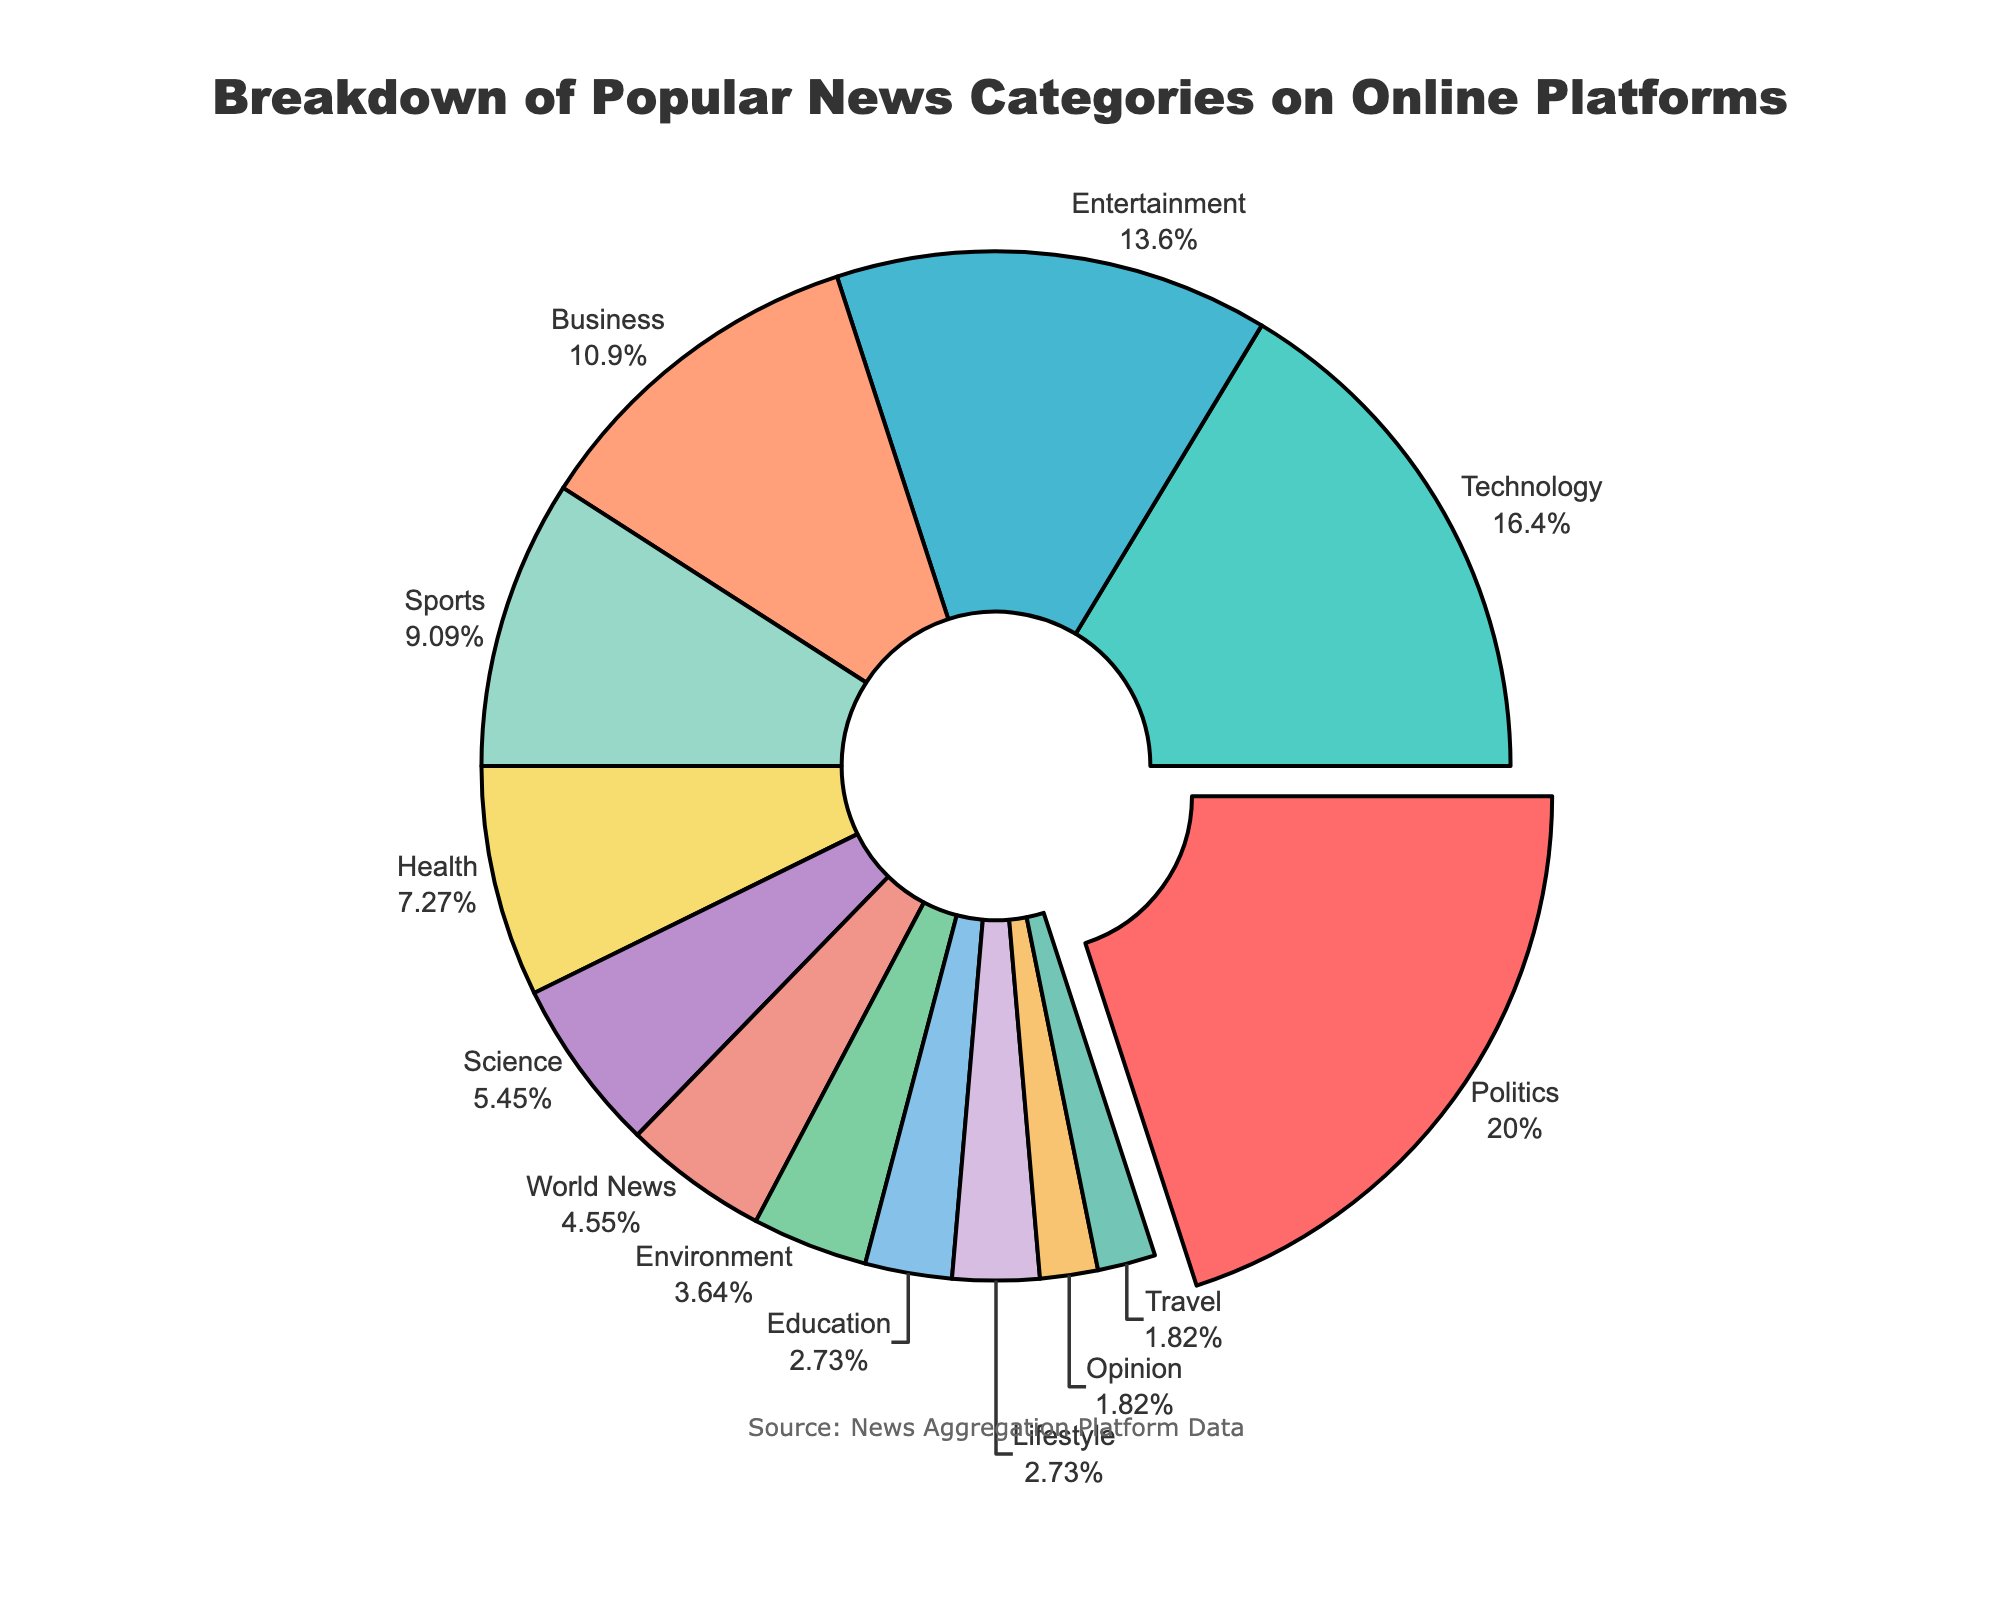What is the most popular news category on online platforms? By looking at the pie chart, the category that has been pulled out slightly more than others is 'Politics'. Also, when referring to the percentages, 'Politics' has the highest percentage at 22%.
Answer: Politics What is the combined percentage for Entertainment and Business categories? To find the combined percentage for Entertainment and Business, add up their individual percentages: 15% for Entertainment and 12% for Business; 15% + 12% = 27%.
Answer: 27% Which two news categories have the lowest percentages, and what are these percentages? By examining the pie chart, the two categories with the smallest slices are 'Opinion' and 'Travel', both having segments with percentages of 2%.
Answer: Opinion and Travel, 2% What is the difference in percentage between Technology and Health categories? Subtract the percentage of the Health category from the Technology category's percentage: 18% (Technology) - 8% (Health) = 10%.
Answer: 10% Does the Sports category have a higher percentage than the Health category? By comparing the two slices on the pie chart, the Sports category is 10% and the Health category is 8%, which means Sports has a higher percentage.
Answer: Yes Which categories have percentages greater than 10%? The slices on the pie chart that have percentages greater than 10% are Politics (22%), Technology (18%), Entertainment (15%), and Business (12%).
Answer: Politics, Technology, Entertainment, Business What is the average percentage for Science, World News, and Environment categories? Add up the percentages for Science (6%), World News (5%), and Environment (4%) and then divide by 3: (6 + 5 + 4) / 3 = 15 / 3 = 5%.
Answer: 5% What category is represented by the light green color, and what is its percentage? In the pie chart, the light green color corresponds to the 'Health' category, which has a percentage of 8%.
Answer: Health, 8% What is the total percentage of categories with less than 5%? The categories with less than 5% are World News (5%), Environment (4%), Education (3%), Lifestyle (3%), Opinion (2%), and Travel (2%). Add their percentages: 4% + 3% + 3% + 2% + 2% = 14%.
Answer: 14% Is the Technology category larger, smaller, or equal to the sum of Sports and Environment categories? The percentage of the Technology category is 18%. The sum of Sports (10%) and Environment (4%) categories is 10% + 4% = 14%. Therefore, Technology's percentage is larger.
Answer: Larger 